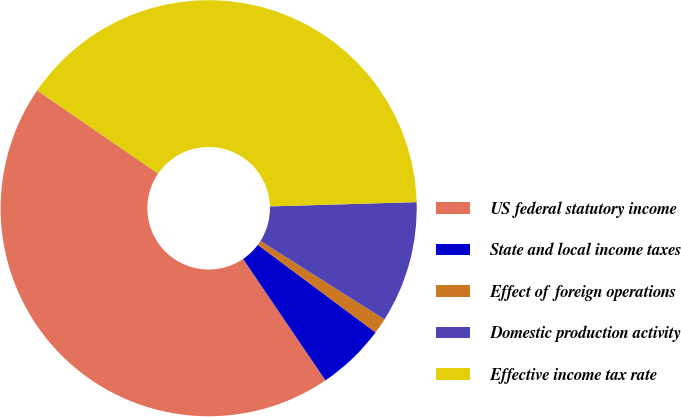Convert chart. <chart><loc_0><loc_0><loc_500><loc_500><pie_chart><fcel>US federal statutory income<fcel>State and local income taxes<fcel>Effect of foreign operations<fcel>Domestic production activity<fcel>Effective income tax rate<nl><fcel>44.07%<fcel>5.33%<fcel>1.21%<fcel>9.44%<fcel>39.95%<nl></chart> 